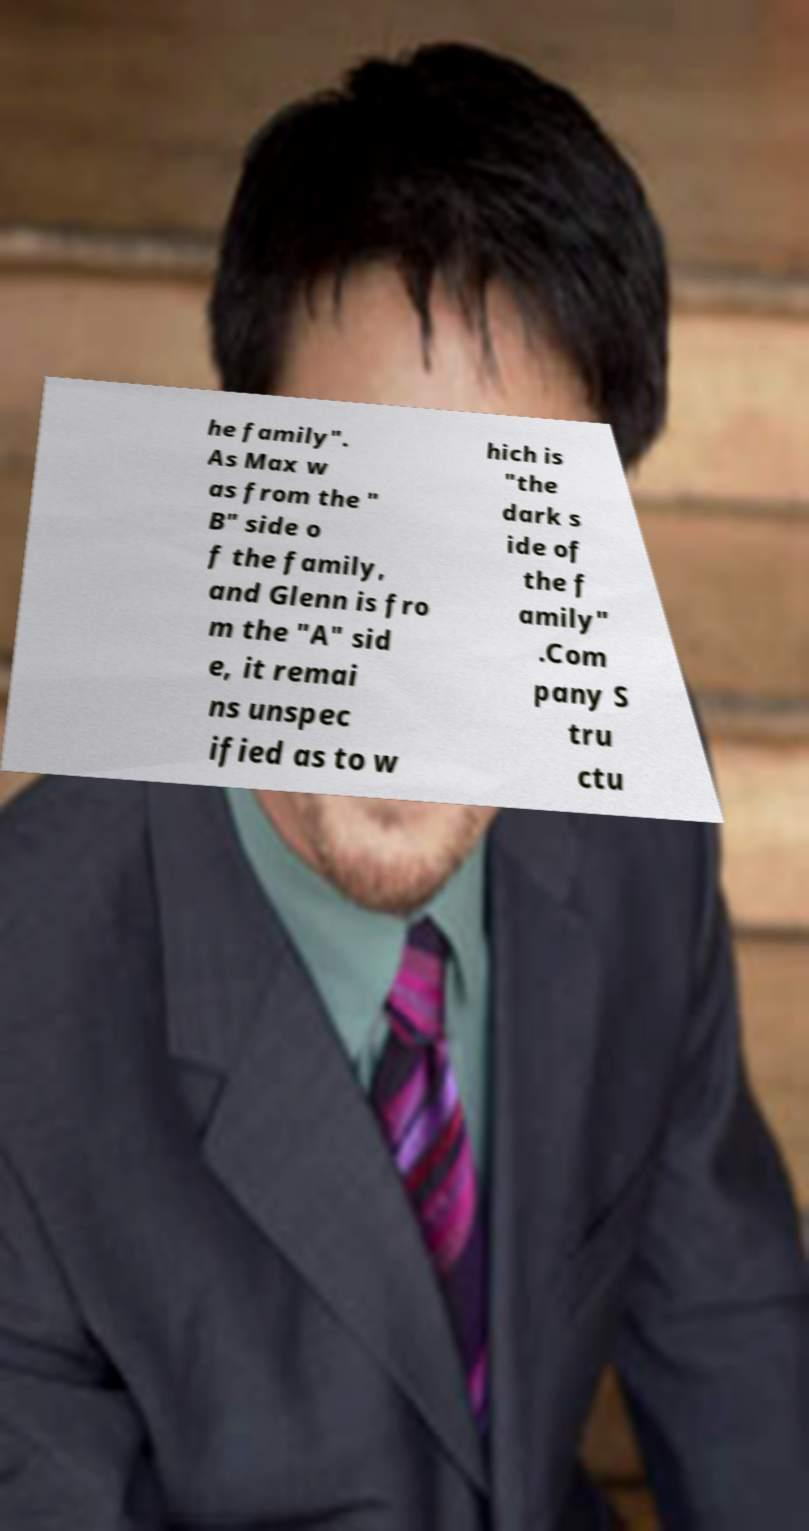Can you accurately transcribe the text from the provided image for me? he family". As Max w as from the " B" side o f the family, and Glenn is fro m the "A" sid e, it remai ns unspec ified as to w hich is "the dark s ide of the f amily" .Com pany S tru ctu 